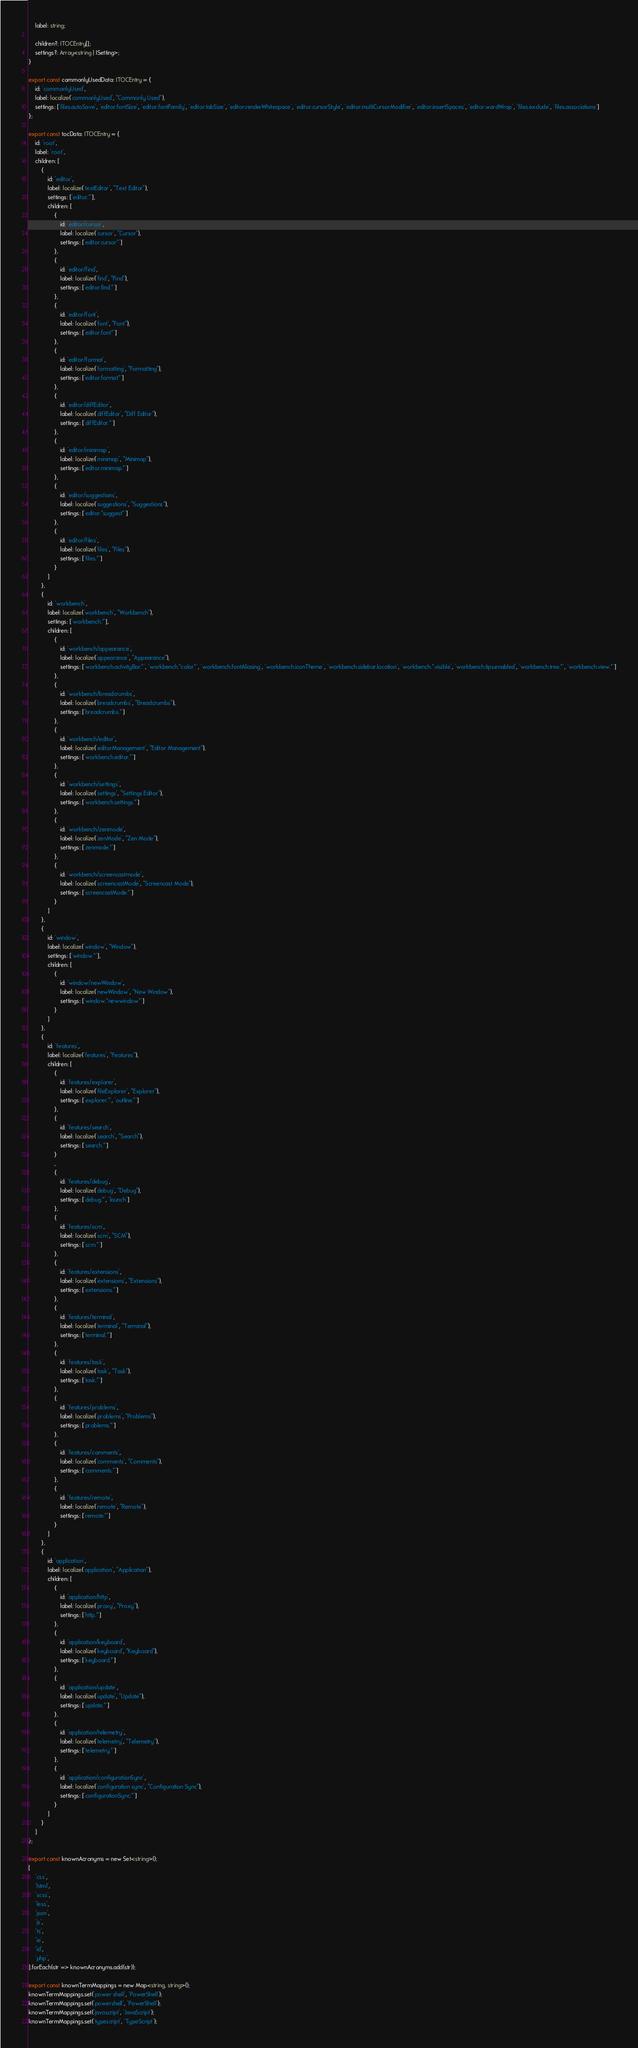<code> <loc_0><loc_0><loc_500><loc_500><_TypeScript_>	label: string;

	children?: ITOCEntry[];
	settings?: Array<string | ISetting>;
}

export const commonlyUsedData: ITOCEntry = {
	id: 'commonlyUsed',
	label: localize('commonlyUsed', "Commonly Used"),
	settings: ['files.autoSave', 'editor.fontSize', 'editor.fontFamily', 'editor.tabSize', 'editor.renderWhitespace', 'editor.cursorStyle', 'editor.multiCursorModifier', 'editor.insertSpaces', 'editor.wordWrap', 'files.exclude', 'files.associations']
};

export const tocData: ITOCEntry = {
	id: 'root',
	label: 'root',
	children: [
		{
			id: 'editor',
			label: localize('textEditor', "Text Editor"),
			settings: ['editor.*'],
			children: [
				{
					id: 'editor/cursor',
					label: localize('cursor', "Cursor"),
					settings: ['editor.cursor*']
				},
				{
					id: 'editor/find',
					label: localize('find', "Find"),
					settings: ['editor.find.*']
				},
				{
					id: 'editor/font',
					label: localize('font', "Font"),
					settings: ['editor.font*']
				},
				{
					id: 'editor/format',
					label: localize('formatting', "Formatting"),
					settings: ['editor.format*']
				},
				{
					id: 'editor/diffEditor',
					label: localize('diffEditor', "Diff Editor"),
					settings: ['diffEditor.*']
				},
				{
					id: 'editor/minimap',
					label: localize('minimap', "Minimap"),
					settings: ['editor.minimap.*']
				},
				{
					id: 'editor/suggestions',
					label: localize('suggestions', "Suggestions"),
					settings: ['editor.*suggest*']
				},
				{
					id: 'editor/files',
					label: localize('files', "Files"),
					settings: ['files.*']
				}
			]
		},
		{
			id: 'workbench',
			label: localize('workbench', "Workbench"),
			settings: ['workbench.*'],
			children: [
				{
					id: 'workbench/appearance',
					label: localize('appearance', "Appearance"),
					settings: ['workbench.activityBar.*', 'workbench.*color*', 'workbench.fontAliasing', 'workbench.iconTheme', 'workbench.sidebar.location', 'workbench.*.visible', 'workbench.tips.enabled', 'workbench.tree.*', 'workbench.view.*']
				},
				{
					id: 'workbench/breadcrumbs',
					label: localize('breadcrumbs', "Breadcrumbs"),
					settings: ['breadcrumbs.*']
				},
				{
					id: 'workbench/editor',
					label: localize('editorManagement', "Editor Management"),
					settings: ['workbench.editor.*']
				},
				{
					id: 'workbench/settings',
					label: localize('settings', "Settings Editor"),
					settings: ['workbench.settings.*']
				},
				{
					id: 'workbench/zenmode',
					label: localize('zenMode', "Zen Mode"),
					settings: ['zenmode.*']
				},
				{
					id: 'workbench/screencastmode',
					label: localize('screencastMode', "Screencast Mode"),
					settings: ['screencastMode.*']
				}
			]
		},
		{
			id: 'window',
			label: localize('window', "Window"),
			settings: ['window.*'],
			children: [
				{
					id: 'window/newWindow',
					label: localize('newWindow', "New Window"),
					settings: ['window.*newwindow*']
				}
			]
		},
		{
			id: 'features',
			label: localize('features', "Features"),
			children: [
				{
					id: 'features/explorer',
					label: localize('fileExplorer', "Explorer"),
					settings: ['explorer.*', 'outline.*']
				},
				{
					id: 'features/search',
					label: localize('search', "Search"),
					settings: ['search.*']
				}
				,
				{
					id: 'features/debug',
					label: localize('debug', "Debug"),
					settings: ['debug.*', 'launch']
				},
				{
					id: 'features/scm',
					label: localize('scm', "SCM"),
					settings: ['scm.*']
				},
				{
					id: 'features/extensions',
					label: localize('extensions', "Extensions"),
					settings: ['extensions.*']
				},
				{
					id: 'features/terminal',
					label: localize('terminal', "Terminal"),
					settings: ['terminal.*']
				},
				{
					id: 'features/task',
					label: localize('task', "Task"),
					settings: ['task.*']
				},
				{
					id: 'features/problems',
					label: localize('problems', "Problems"),
					settings: ['problems.*']
				},
				{
					id: 'features/comments',
					label: localize('comments', "Comments"),
					settings: ['comments.*']
				},
				{
					id: 'features/remote',
					label: localize('remote', "Remote"),
					settings: ['remote.*']
				}
			]
		},
		{
			id: 'application',
			label: localize('application', "Application"),
			children: [
				{
					id: 'application/http',
					label: localize('proxy', "Proxy"),
					settings: ['http.*']
				},
				{
					id: 'application/keyboard',
					label: localize('keyboard', "Keyboard"),
					settings: ['keyboard.*']
				},
				{
					id: 'application/update',
					label: localize('update', "Update"),
					settings: ['update.*']
				},
				{
					id: 'application/telemetry',
					label: localize('telemetry', "Telemetry"),
					settings: ['telemetry.*']
				},
				{
					id: 'application/configurationSync',
					label: localize('configuration sync', "Configuration Sync"),
					settings: ['configurationSync.*']
				}
			]
		}
	]
};

export const knownAcronyms = new Set<string>();
[
	'css',
	'html',
	'scss',
	'less',
	'json',
	'js',
	'ts',
	'ie',
	'id',
	'php',
].forEach(str => knownAcronyms.add(str));

export const knownTermMappings = new Map<string, string>();
knownTermMappings.set('power shell', 'PowerShell');
knownTermMappings.set('powershell', 'PowerShell');
knownTermMappings.set('javascript', 'JavaScript');
knownTermMappings.set('typescript', 'TypeScript');
</code> 